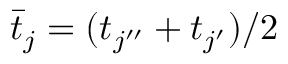Convert formula to latex. <formula><loc_0><loc_0><loc_500><loc_500>\bar { t } _ { j } = ( t _ { j ^ { \prime \prime } } + t _ { j ^ { \prime } } ) / 2</formula> 